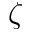Convert formula to latex. <formula><loc_0><loc_0><loc_500><loc_500>\zeta</formula> 